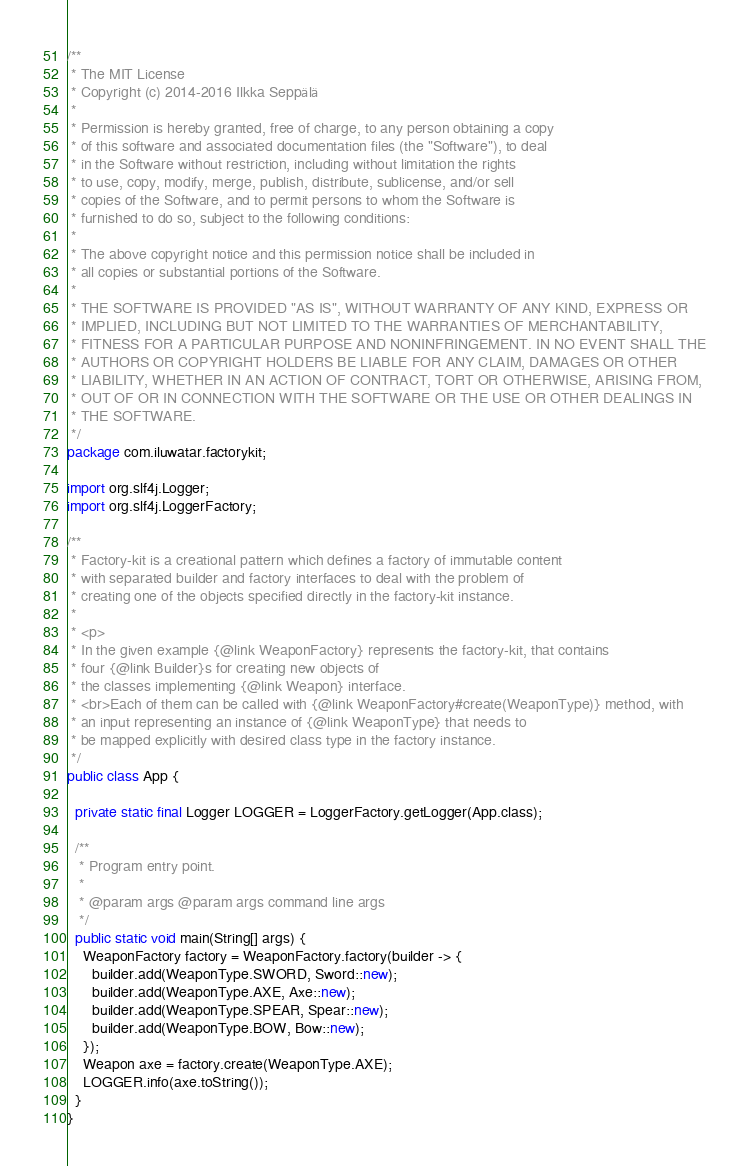Convert code to text. <code><loc_0><loc_0><loc_500><loc_500><_Java_>/**
 * The MIT License
 * Copyright (c) 2014-2016 Ilkka Seppälä
 *
 * Permission is hereby granted, free of charge, to any person obtaining a copy
 * of this software and associated documentation files (the "Software"), to deal
 * in the Software without restriction, including without limitation the rights
 * to use, copy, modify, merge, publish, distribute, sublicense, and/or sell
 * copies of the Software, and to permit persons to whom the Software is
 * furnished to do so, subject to the following conditions:
 *
 * The above copyright notice and this permission notice shall be included in
 * all copies or substantial portions of the Software.
 *
 * THE SOFTWARE IS PROVIDED "AS IS", WITHOUT WARRANTY OF ANY KIND, EXPRESS OR
 * IMPLIED, INCLUDING BUT NOT LIMITED TO THE WARRANTIES OF MERCHANTABILITY,
 * FITNESS FOR A PARTICULAR PURPOSE AND NONINFRINGEMENT. IN NO EVENT SHALL THE
 * AUTHORS OR COPYRIGHT HOLDERS BE LIABLE FOR ANY CLAIM, DAMAGES OR OTHER
 * LIABILITY, WHETHER IN AN ACTION OF CONTRACT, TORT OR OTHERWISE, ARISING FROM,
 * OUT OF OR IN CONNECTION WITH THE SOFTWARE OR THE USE OR OTHER DEALINGS IN
 * THE SOFTWARE.
 */
package com.iluwatar.factorykit;

import org.slf4j.Logger;
import org.slf4j.LoggerFactory;

/**
 * Factory-kit is a creational pattern which defines a factory of immutable content
 * with separated builder and factory interfaces to deal with the problem of
 * creating one of the objects specified directly in the factory-kit instance.
 *
 * <p>
 * In the given example {@link WeaponFactory} represents the factory-kit, that contains
 * four {@link Builder}s for creating new objects of
 * the classes implementing {@link Weapon} interface.
 * <br>Each of them can be called with {@link WeaponFactory#create(WeaponType)} method, with
 * an input representing an instance of {@link WeaponType} that needs to
 * be mapped explicitly with desired class type in the factory instance.
 */
public class App {

  private static final Logger LOGGER = LoggerFactory.getLogger(App.class);

  /**
   * Program entry point.
   *
   * @param args @param args command line args
   */
  public static void main(String[] args) {
    WeaponFactory factory = WeaponFactory.factory(builder -> {
      builder.add(WeaponType.SWORD, Sword::new);
      builder.add(WeaponType.AXE, Axe::new);
      builder.add(WeaponType.SPEAR, Spear::new);
      builder.add(WeaponType.BOW, Bow::new);
    });
    Weapon axe = factory.create(WeaponType.AXE);
    LOGGER.info(axe.toString());
  }
}
</code> 